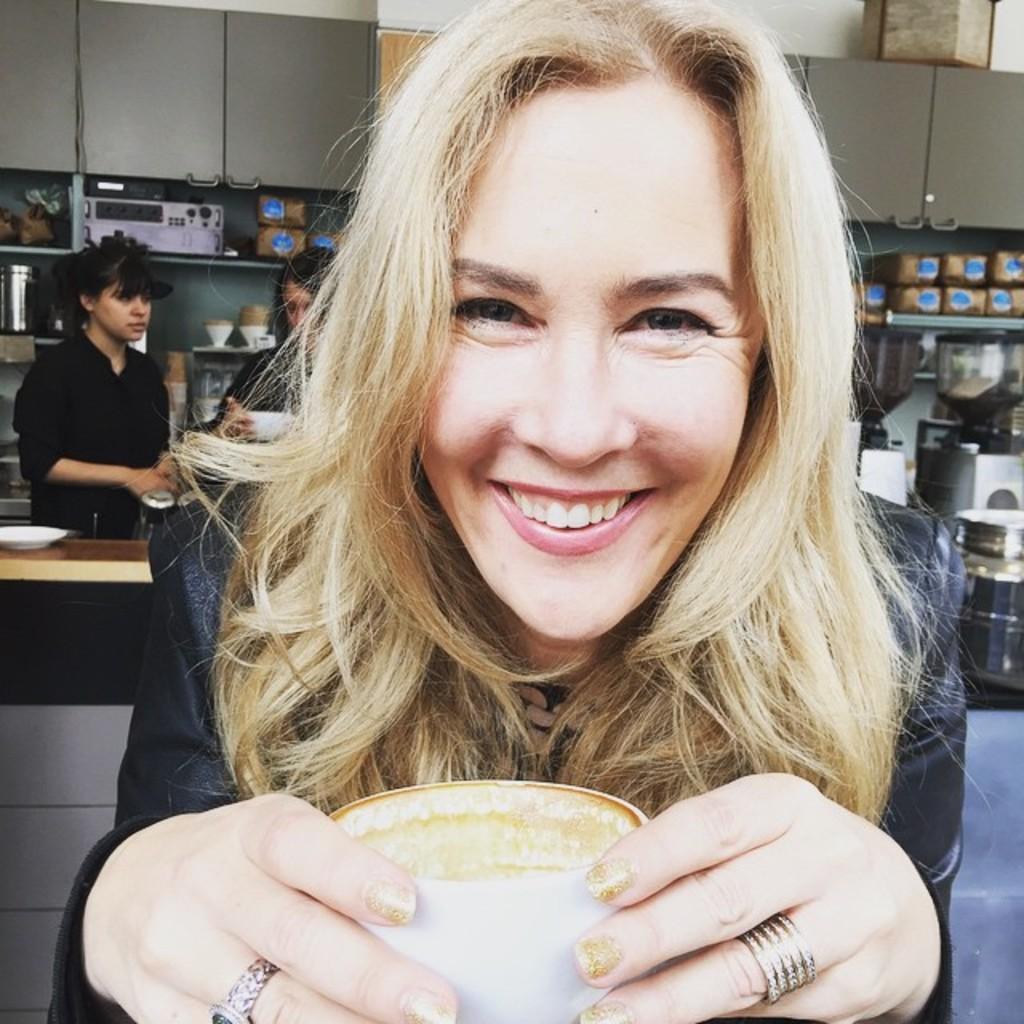How would you summarize this image in a sentence or two? In this picture I can observe a woman holding a cup in her hands. She is smiling. In the background there are some people standing behind the desk. I can observe some eatables placed in the racks in the background. 